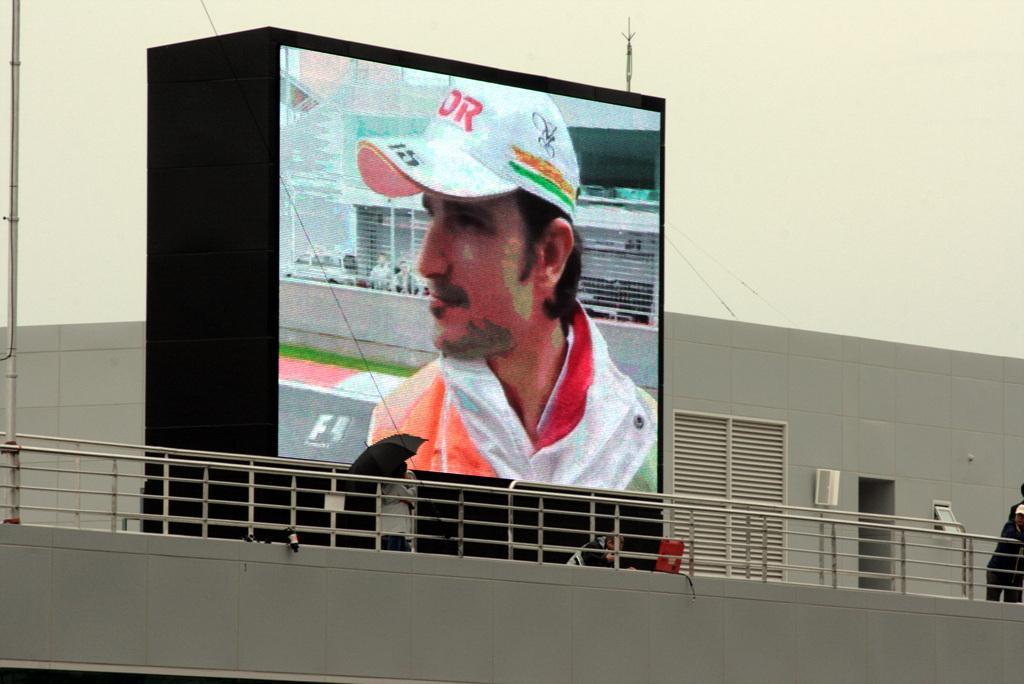Can you describe this image briefly? In the center of this picture we can see an image of a person and image of some other objects on the display of digital screen and we can see the railings, group of persons, window blinds and some other objects. 